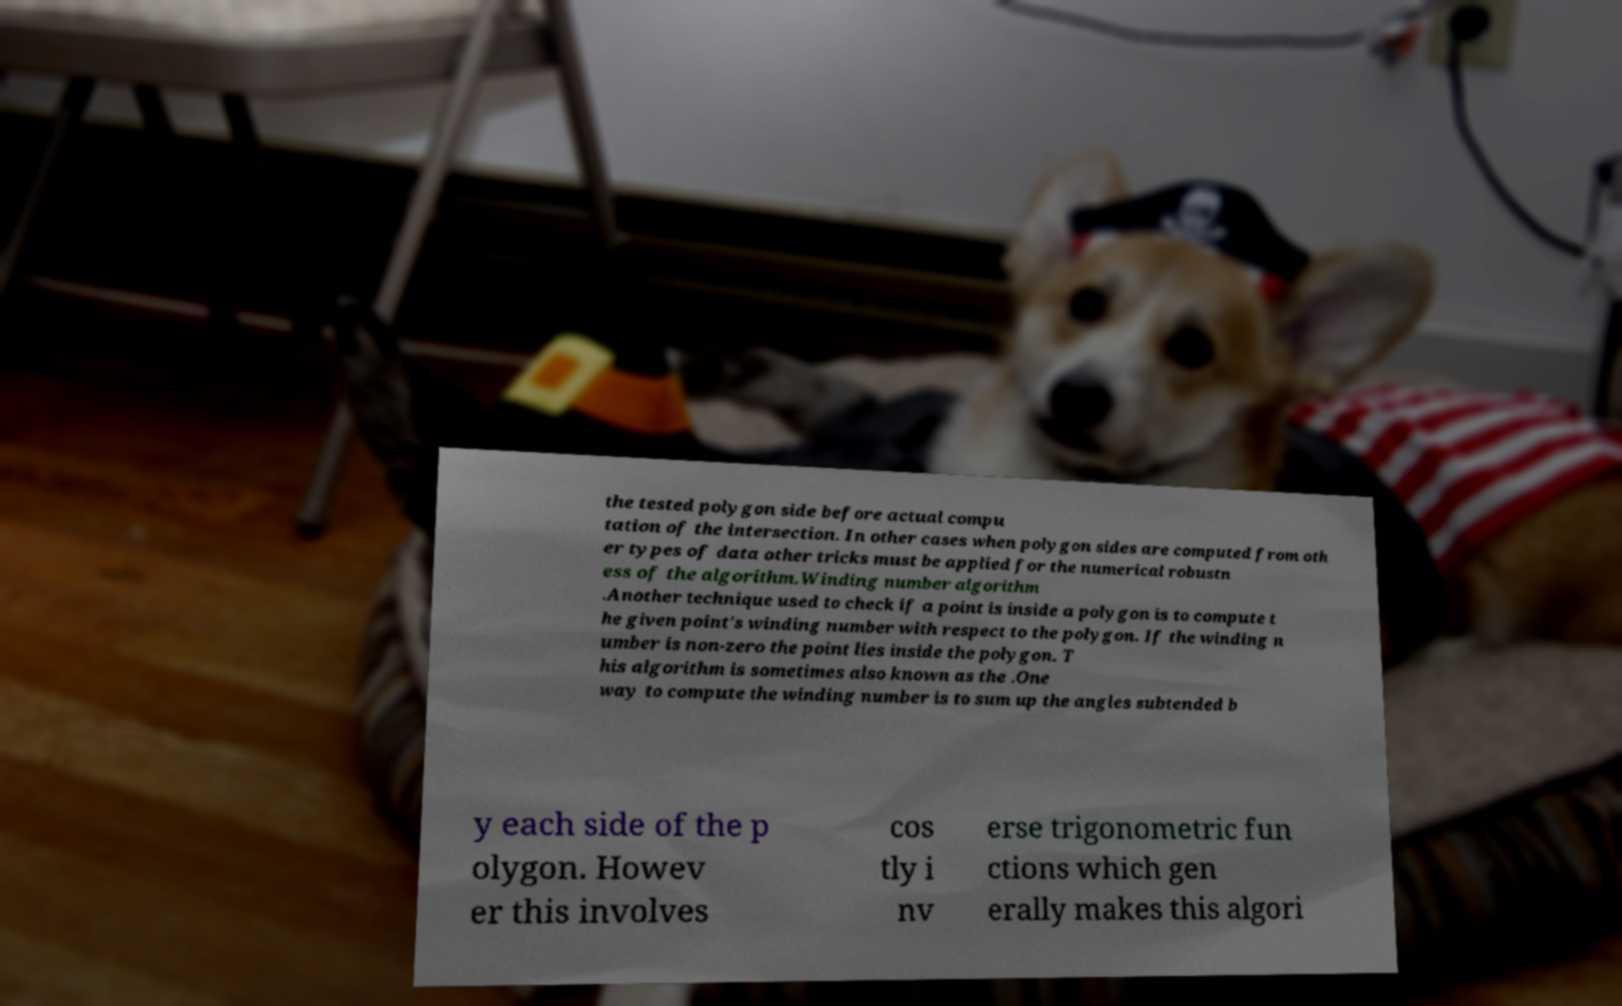Could you assist in decoding the text presented in this image and type it out clearly? the tested polygon side before actual compu tation of the intersection. In other cases when polygon sides are computed from oth er types of data other tricks must be applied for the numerical robustn ess of the algorithm.Winding number algorithm .Another technique used to check if a point is inside a polygon is to compute t he given point's winding number with respect to the polygon. If the winding n umber is non-zero the point lies inside the polygon. T his algorithm is sometimes also known as the .One way to compute the winding number is to sum up the angles subtended b y each side of the p olygon. Howev er this involves cos tly i nv erse trigonometric fun ctions which gen erally makes this algori 